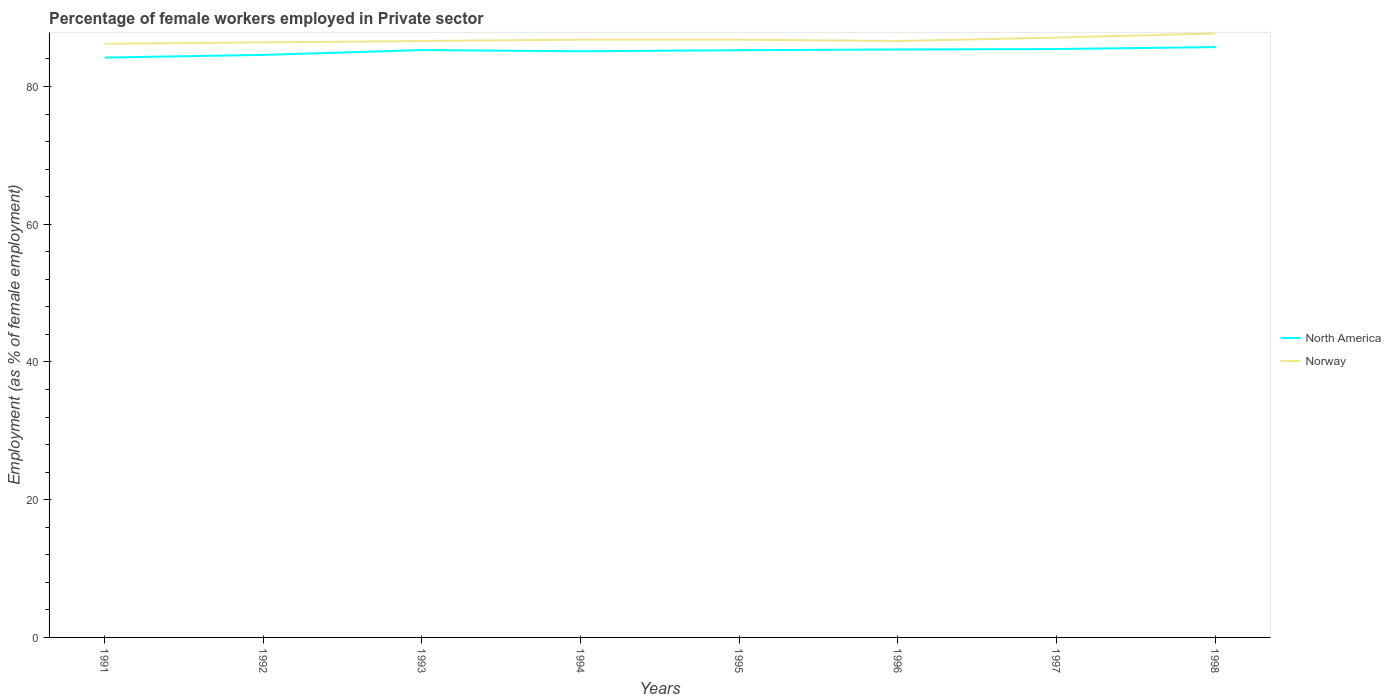Is the number of lines equal to the number of legend labels?
Your answer should be compact. Yes. Across all years, what is the maximum percentage of females employed in Private sector in Norway?
Your response must be concise. 86.2. In which year was the percentage of females employed in Private sector in Norway maximum?
Provide a succinct answer. 1991. What is the total percentage of females employed in Private sector in North America in the graph?
Make the answer very short. -1.18. What is the difference between the highest and the second highest percentage of females employed in Private sector in North America?
Provide a short and direct response. 1.52. What is the difference between the highest and the lowest percentage of females employed in Private sector in North America?
Provide a short and direct response. 5. Is the percentage of females employed in Private sector in North America strictly greater than the percentage of females employed in Private sector in Norway over the years?
Offer a terse response. Yes. How many years are there in the graph?
Your answer should be very brief. 8. What is the difference between two consecutive major ticks on the Y-axis?
Provide a short and direct response. 20. Does the graph contain any zero values?
Ensure brevity in your answer.  No. Does the graph contain grids?
Your answer should be very brief. No. Where does the legend appear in the graph?
Provide a succinct answer. Center right. How are the legend labels stacked?
Provide a short and direct response. Vertical. What is the title of the graph?
Offer a terse response. Percentage of female workers employed in Private sector. What is the label or title of the X-axis?
Make the answer very short. Years. What is the label or title of the Y-axis?
Your answer should be very brief. Employment (as % of female employment). What is the Employment (as % of female employment) of North America in 1991?
Ensure brevity in your answer.  84.2. What is the Employment (as % of female employment) in Norway in 1991?
Keep it short and to the point. 86.2. What is the Employment (as % of female employment) of North America in 1992?
Provide a succinct answer. 84.59. What is the Employment (as % of female employment) in Norway in 1992?
Provide a succinct answer. 86.4. What is the Employment (as % of female employment) in North America in 1993?
Your answer should be very brief. 85.29. What is the Employment (as % of female employment) in Norway in 1993?
Keep it short and to the point. 86.6. What is the Employment (as % of female employment) in North America in 1994?
Offer a very short reply. 85.11. What is the Employment (as % of female employment) of Norway in 1994?
Give a very brief answer. 86.8. What is the Employment (as % of female employment) of North America in 1995?
Make the answer very short. 85.27. What is the Employment (as % of female employment) in Norway in 1995?
Keep it short and to the point. 86.8. What is the Employment (as % of female employment) in North America in 1996?
Give a very brief answer. 85.38. What is the Employment (as % of female employment) in Norway in 1996?
Give a very brief answer. 86.6. What is the Employment (as % of female employment) of North America in 1997?
Offer a very short reply. 85.44. What is the Employment (as % of female employment) in Norway in 1997?
Your answer should be compact. 87.1. What is the Employment (as % of female employment) in North America in 1998?
Offer a terse response. 85.72. What is the Employment (as % of female employment) of Norway in 1998?
Your answer should be very brief. 87.7. Across all years, what is the maximum Employment (as % of female employment) in North America?
Your answer should be very brief. 85.72. Across all years, what is the maximum Employment (as % of female employment) in Norway?
Provide a succinct answer. 87.7. Across all years, what is the minimum Employment (as % of female employment) of North America?
Ensure brevity in your answer.  84.2. Across all years, what is the minimum Employment (as % of female employment) in Norway?
Ensure brevity in your answer.  86.2. What is the total Employment (as % of female employment) in North America in the graph?
Your answer should be very brief. 680.99. What is the total Employment (as % of female employment) of Norway in the graph?
Your answer should be compact. 694.2. What is the difference between the Employment (as % of female employment) in North America in 1991 and that in 1992?
Make the answer very short. -0.39. What is the difference between the Employment (as % of female employment) in Norway in 1991 and that in 1992?
Your answer should be compact. -0.2. What is the difference between the Employment (as % of female employment) of North America in 1991 and that in 1993?
Make the answer very short. -1.09. What is the difference between the Employment (as % of female employment) in Norway in 1991 and that in 1993?
Your answer should be very brief. -0.4. What is the difference between the Employment (as % of female employment) in North America in 1991 and that in 1994?
Provide a short and direct response. -0.91. What is the difference between the Employment (as % of female employment) in Norway in 1991 and that in 1994?
Give a very brief answer. -0.6. What is the difference between the Employment (as % of female employment) in North America in 1991 and that in 1995?
Provide a short and direct response. -1.07. What is the difference between the Employment (as % of female employment) in Norway in 1991 and that in 1995?
Your answer should be compact. -0.6. What is the difference between the Employment (as % of female employment) in North America in 1991 and that in 1996?
Your answer should be very brief. -1.18. What is the difference between the Employment (as % of female employment) in Norway in 1991 and that in 1996?
Provide a succinct answer. -0.4. What is the difference between the Employment (as % of female employment) of North America in 1991 and that in 1997?
Ensure brevity in your answer.  -1.24. What is the difference between the Employment (as % of female employment) in Norway in 1991 and that in 1997?
Offer a very short reply. -0.9. What is the difference between the Employment (as % of female employment) in North America in 1991 and that in 1998?
Your answer should be very brief. -1.52. What is the difference between the Employment (as % of female employment) of Norway in 1991 and that in 1998?
Make the answer very short. -1.5. What is the difference between the Employment (as % of female employment) in North America in 1992 and that in 1993?
Ensure brevity in your answer.  -0.7. What is the difference between the Employment (as % of female employment) in Norway in 1992 and that in 1993?
Offer a terse response. -0.2. What is the difference between the Employment (as % of female employment) of North America in 1992 and that in 1994?
Your response must be concise. -0.53. What is the difference between the Employment (as % of female employment) in Norway in 1992 and that in 1994?
Your response must be concise. -0.4. What is the difference between the Employment (as % of female employment) of North America in 1992 and that in 1995?
Ensure brevity in your answer.  -0.68. What is the difference between the Employment (as % of female employment) in Norway in 1992 and that in 1995?
Provide a succinct answer. -0.4. What is the difference between the Employment (as % of female employment) in North America in 1992 and that in 1996?
Make the answer very short. -0.79. What is the difference between the Employment (as % of female employment) in North America in 1992 and that in 1997?
Ensure brevity in your answer.  -0.85. What is the difference between the Employment (as % of female employment) of Norway in 1992 and that in 1997?
Give a very brief answer. -0.7. What is the difference between the Employment (as % of female employment) in North America in 1992 and that in 1998?
Your answer should be compact. -1.13. What is the difference between the Employment (as % of female employment) in North America in 1993 and that in 1994?
Make the answer very short. 0.17. What is the difference between the Employment (as % of female employment) in North America in 1993 and that in 1995?
Your response must be concise. 0.02. What is the difference between the Employment (as % of female employment) in Norway in 1993 and that in 1995?
Offer a terse response. -0.2. What is the difference between the Employment (as % of female employment) in North America in 1993 and that in 1996?
Ensure brevity in your answer.  -0.09. What is the difference between the Employment (as % of female employment) of Norway in 1993 and that in 1996?
Keep it short and to the point. 0. What is the difference between the Employment (as % of female employment) in North America in 1993 and that in 1997?
Keep it short and to the point. -0.15. What is the difference between the Employment (as % of female employment) of Norway in 1993 and that in 1997?
Offer a terse response. -0.5. What is the difference between the Employment (as % of female employment) of North America in 1993 and that in 1998?
Your answer should be very brief. -0.43. What is the difference between the Employment (as % of female employment) of Norway in 1993 and that in 1998?
Your answer should be compact. -1.1. What is the difference between the Employment (as % of female employment) of North America in 1994 and that in 1995?
Ensure brevity in your answer.  -0.15. What is the difference between the Employment (as % of female employment) in Norway in 1994 and that in 1995?
Ensure brevity in your answer.  0. What is the difference between the Employment (as % of female employment) of North America in 1994 and that in 1996?
Make the answer very short. -0.26. What is the difference between the Employment (as % of female employment) in North America in 1994 and that in 1997?
Provide a short and direct response. -0.32. What is the difference between the Employment (as % of female employment) in Norway in 1994 and that in 1997?
Provide a succinct answer. -0.3. What is the difference between the Employment (as % of female employment) in North America in 1994 and that in 1998?
Provide a short and direct response. -0.6. What is the difference between the Employment (as % of female employment) of North America in 1995 and that in 1996?
Offer a terse response. -0.11. What is the difference between the Employment (as % of female employment) in North America in 1995 and that in 1997?
Offer a terse response. -0.17. What is the difference between the Employment (as % of female employment) of North America in 1995 and that in 1998?
Provide a short and direct response. -0.45. What is the difference between the Employment (as % of female employment) of Norway in 1995 and that in 1998?
Your answer should be very brief. -0.9. What is the difference between the Employment (as % of female employment) in North America in 1996 and that in 1997?
Your answer should be compact. -0.06. What is the difference between the Employment (as % of female employment) in Norway in 1996 and that in 1997?
Offer a terse response. -0.5. What is the difference between the Employment (as % of female employment) of North America in 1996 and that in 1998?
Your response must be concise. -0.34. What is the difference between the Employment (as % of female employment) of Norway in 1996 and that in 1998?
Your answer should be compact. -1.1. What is the difference between the Employment (as % of female employment) of North America in 1997 and that in 1998?
Provide a short and direct response. -0.28. What is the difference between the Employment (as % of female employment) in North America in 1991 and the Employment (as % of female employment) in Norway in 1992?
Offer a terse response. -2.2. What is the difference between the Employment (as % of female employment) in North America in 1991 and the Employment (as % of female employment) in Norway in 1993?
Give a very brief answer. -2.4. What is the difference between the Employment (as % of female employment) of North America in 1991 and the Employment (as % of female employment) of Norway in 1994?
Provide a succinct answer. -2.6. What is the difference between the Employment (as % of female employment) of North America in 1991 and the Employment (as % of female employment) of Norway in 1995?
Give a very brief answer. -2.6. What is the difference between the Employment (as % of female employment) of North America in 1991 and the Employment (as % of female employment) of Norway in 1996?
Provide a short and direct response. -2.4. What is the difference between the Employment (as % of female employment) in North America in 1991 and the Employment (as % of female employment) in Norway in 1997?
Provide a succinct answer. -2.9. What is the difference between the Employment (as % of female employment) of North America in 1991 and the Employment (as % of female employment) of Norway in 1998?
Make the answer very short. -3.5. What is the difference between the Employment (as % of female employment) of North America in 1992 and the Employment (as % of female employment) of Norway in 1993?
Offer a terse response. -2.01. What is the difference between the Employment (as % of female employment) in North America in 1992 and the Employment (as % of female employment) in Norway in 1994?
Your response must be concise. -2.21. What is the difference between the Employment (as % of female employment) in North America in 1992 and the Employment (as % of female employment) in Norway in 1995?
Offer a very short reply. -2.21. What is the difference between the Employment (as % of female employment) of North America in 1992 and the Employment (as % of female employment) of Norway in 1996?
Keep it short and to the point. -2.01. What is the difference between the Employment (as % of female employment) in North America in 1992 and the Employment (as % of female employment) in Norway in 1997?
Make the answer very short. -2.51. What is the difference between the Employment (as % of female employment) in North America in 1992 and the Employment (as % of female employment) in Norway in 1998?
Keep it short and to the point. -3.11. What is the difference between the Employment (as % of female employment) of North America in 1993 and the Employment (as % of female employment) of Norway in 1994?
Your answer should be compact. -1.51. What is the difference between the Employment (as % of female employment) of North America in 1993 and the Employment (as % of female employment) of Norway in 1995?
Offer a terse response. -1.51. What is the difference between the Employment (as % of female employment) in North America in 1993 and the Employment (as % of female employment) in Norway in 1996?
Provide a succinct answer. -1.31. What is the difference between the Employment (as % of female employment) of North America in 1993 and the Employment (as % of female employment) of Norway in 1997?
Keep it short and to the point. -1.81. What is the difference between the Employment (as % of female employment) in North America in 1993 and the Employment (as % of female employment) in Norway in 1998?
Keep it short and to the point. -2.41. What is the difference between the Employment (as % of female employment) in North America in 1994 and the Employment (as % of female employment) in Norway in 1995?
Provide a short and direct response. -1.69. What is the difference between the Employment (as % of female employment) of North America in 1994 and the Employment (as % of female employment) of Norway in 1996?
Offer a very short reply. -1.49. What is the difference between the Employment (as % of female employment) of North America in 1994 and the Employment (as % of female employment) of Norway in 1997?
Your answer should be compact. -1.99. What is the difference between the Employment (as % of female employment) of North America in 1994 and the Employment (as % of female employment) of Norway in 1998?
Provide a succinct answer. -2.59. What is the difference between the Employment (as % of female employment) of North America in 1995 and the Employment (as % of female employment) of Norway in 1996?
Keep it short and to the point. -1.33. What is the difference between the Employment (as % of female employment) of North America in 1995 and the Employment (as % of female employment) of Norway in 1997?
Provide a short and direct response. -1.83. What is the difference between the Employment (as % of female employment) in North America in 1995 and the Employment (as % of female employment) in Norway in 1998?
Your answer should be compact. -2.43. What is the difference between the Employment (as % of female employment) in North America in 1996 and the Employment (as % of female employment) in Norway in 1997?
Your answer should be compact. -1.72. What is the difference between the Employment (as % of female employment) in North America in 1996 and the Employment (as % of female employment) in Norway in 1998?
Offer a very short reply. -2.32. What is the difference between the Employment (as % of female employment) of North America in 1997 and the Employment (as % of female employment) of Norway in 1998?
Provide a succinct answer. -2.26. What is the average Employment (as % of female employment) in North America per year?
Make the answer very short. 85.12. What is the average Employment (as % of female employment) in Norway per year?
Your answer should be compact. 86.78. In the year 1991, what is the difference between the Employment (as % of female employment) of North America and Employment (as % of female employment) of Norway?
Your response must be concise. -2. In the year 1992, what is the difference between the Employment (as % of female employment) of North America and Employment (as % of female employment) of Norway?
Offer a terse response. -1.81. In the year 1993, what is the difference between the Employment (as % of female employment) of North America and Employment (as % of female employment) of Norway?
Make the answer very short. -1.31. In the year 1994, what is the difference between the Employment (as % of female employment) in North America and Employment (as % of female employment) in Norway?
Make the answer very short. -1.69. In the year 1995, what is the difference between the Employment (as % of female employment) in North America and Employment (as % of female employment) in Norway?
Ensure brevity in your answer.  -1.53. In the year 1996, what is the difference between the Employment (as % of female employment) of North America and Employment (as % of female employment) of Norway?
Make the answer very short. -1.22. In the year 1997, what is the difference between the Employment (as % of female employment) of North America and Employment (as % of female employment) of Norway?
Keep it short and to the point. -1.66. In the year 1998, what is the difference between the Employment (as % of female employment) of North America and Employment (as % of female employment) of Norway?
Offer a terse response. -1.98. What is the ratio of the Employment (as % of female employment) in North America in 1991 to that in 1993?
Offer a terse response. 0.99. What is the ratio of the Employment (as % of female employment) in North America in 1991 to that in 1994?
Offer a very short reply. 0.99. What is the ratio of the Employment (as % of female employment) in Norway in 1991 to that in 1994?
Your response must be concise. 0.99. What is the ratio of the Employment (as % of female employment) of North America in 1991 to that in 1995?
Keep it short and to the point. 0.99. What is the ratio of the Employment (as % of female employment) in North America in 1991 to that in 1996?
Give a very brief answer. 0.99. What is the ratio of the Employment (as % of female employment) of Norway in 1991 to that in 1996?
Provide a succinct answer. 1. What is the ratio of the Employment (as % of female employment) in North America in 1991 to that in 1997?
Make the answer very short. 0.99. What is the ratio of the Employment (as % of female employment) in North America in 1991 to that in 1998?
Provide a succinct answer. 0.98. What is the ratio of the Employment (as % of female employment) of Norway in 1991 to that in 1998?
Provide a short and direct response. 0.98. What is the ratio of the Employment (as % of female employment) in North America in 1992 to that in 1994?
Make the answer very short. 0.99. What is the ratio of the Employment (as % of female employment) in Norway in 1992 to that in 1994?
Offer a very short reply. 1. What is the ratio of the Employment (as % of female employment) of North America in 1992 to that in 1996?
Provide a short and direct response. 0.99. What is the ratio of the Employment (as % of female employment) of Norway in 1992 to that in 1996?
Provide a short and direct response. 1. What is the ratio of the Employment (as % of female employment) of Norway in 1992 to that in 1997?
Ensure brevity in your answer.  0.99. What is the ratio of the Employment (as % of female employment) in Norway in 1992 to that in 1998?
Your response must be concise. 0.99. What is the ratio of the Employment (as % of female employment) of Norway in 1993 to that in 1994?
Ensure brevity in your answer.  1. What is the ratio of the Employment (as % of female employment) of North America in 1993 to that in 1996?
Provide a succinct answer. 1. What is the ratio of the Employment (as % of female employment) of Norway in 1993 to that in 1996?
Ensure brevity in your answer.  1. What is the ratio of the Employment (as % of female employment) in North America in 1993 to that in 1997?
Keep it short and to the point. 1. What is the ratio of the Employment (as % of female employment) of Norway in 1993 to that in 1998?
Provide a succinct answer. 0.99. What is the ratio of the Employment (as % of female employment) of North America in 1994 to that in 1995?
Keep it short and to the point. 1. What is the ratio of the Employment (as % of female employment) of Norway in 1994 to that in 1995?
Give a very brief answer. 1. What is the ratio of the Employment (as % of female employment) of Norway in 1994 to that in 1997?
Offer a very short reply. 1. What is the ratio of the Employment (as % of female employment) in North America in 1994 to that in 1998?
Make the answer very short. 0.99. What is the ratio of the Employment (as % of female employment) in North America in 1995 to that in 1996?
Your response must be concise. 1. What is the ratio of the Employment (as % of female employment) in North America in 1995 to that in 1997?
Offer a very short reply. 1. What is the ratio of the Employment (as % of female employment) of Norway in 1995 to that in 1998?
Ensure brevity in your answer.  0.99. What is the ratio of the Employment (as % of female employment) in North America in 1996 to that in 1997?
Give a very brief answer. 1. What is the ratio of the Employment (as % of female employment) of Norway in 1996 to that in 1997?
Offer a very short reply. 0.99. What is the ratio of the Employment (as % of female employment) in North America in 1996 to that in 1998?
Keep it short and to the point. 1. What is the ratio of the Employment (as % of female employment) of Norway in 1996 to that in 1998?
Your response must be concise. 0.99. What is the ratio of the Employment (as % of female employment) in North America in 1997 to that in 1998?
Provide a succinct answer. 1. What is the ratio of the Employment (as % of female employment) in Norway in 1997 to that in 1998?
Ensure brevity in your answer.  0.99. What is the difference between the highest and the second highest Employment (as % of female employment) of North America?
Provide a short and direct response. 0.28. What is the difference between the highest and the second highest Employment (as % of female employment) in Norway?
Your answer should be compact. 0.6. What is the difference between the highest and the lowest Employment (as % of female employment) of North America?
Your response must be concise. 1.52. What is the difference between the highest and the lowest Employment (as % of female employment) in Norway?
Offer a terse response. 1.5. 